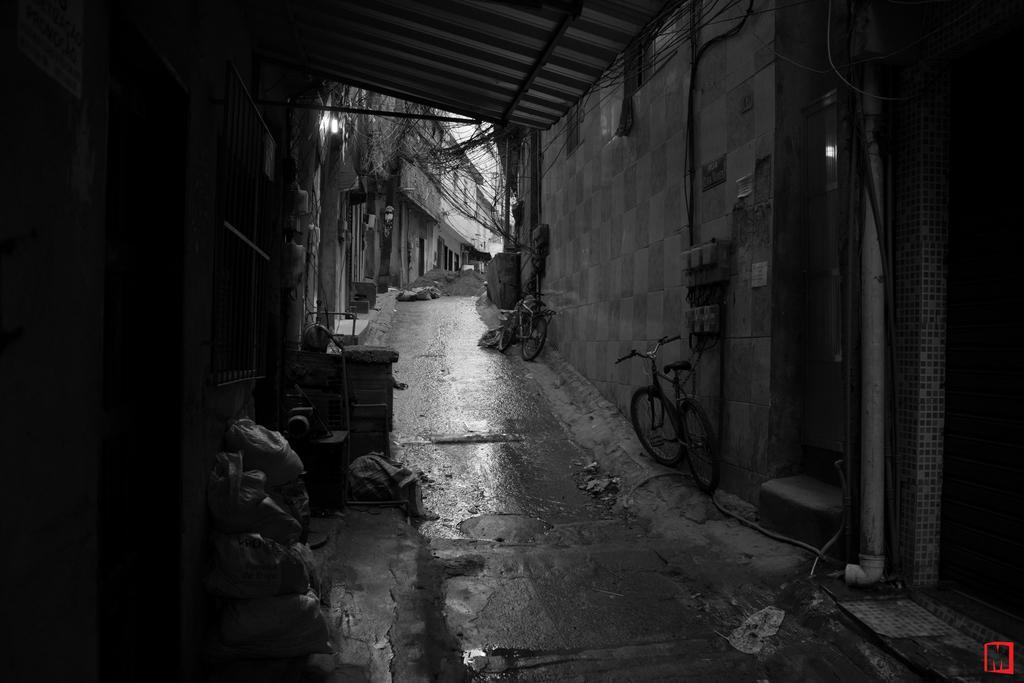Could you give a brief overview of what you see in this image? In this picture we can see buildings, on the right side there are two bicycles, a pipe and wires, there are some bags at the left bottom, it is a black and white picture, we can see electric boards here. 